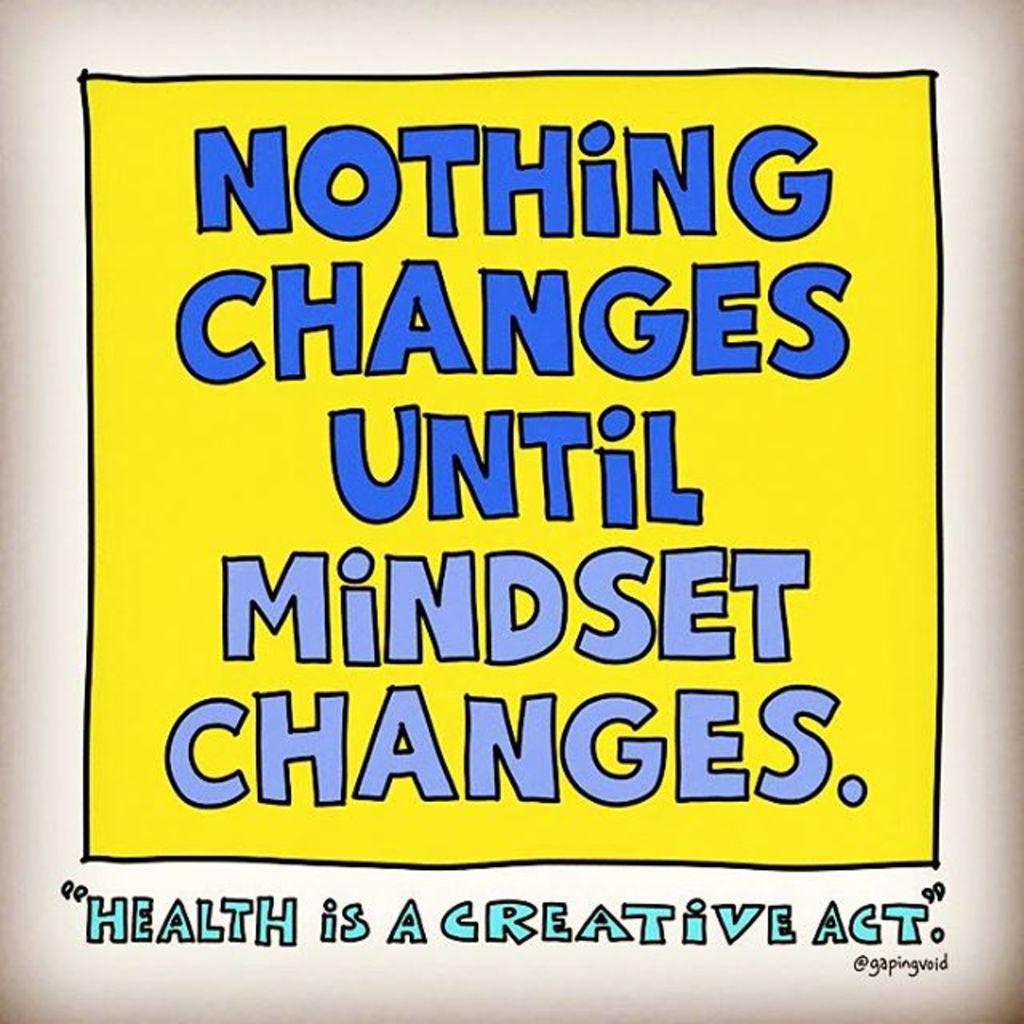What needs to change first?
Your answer should be compact. Mindset. What is a creative act?
Your answer should be very brief. Health. 